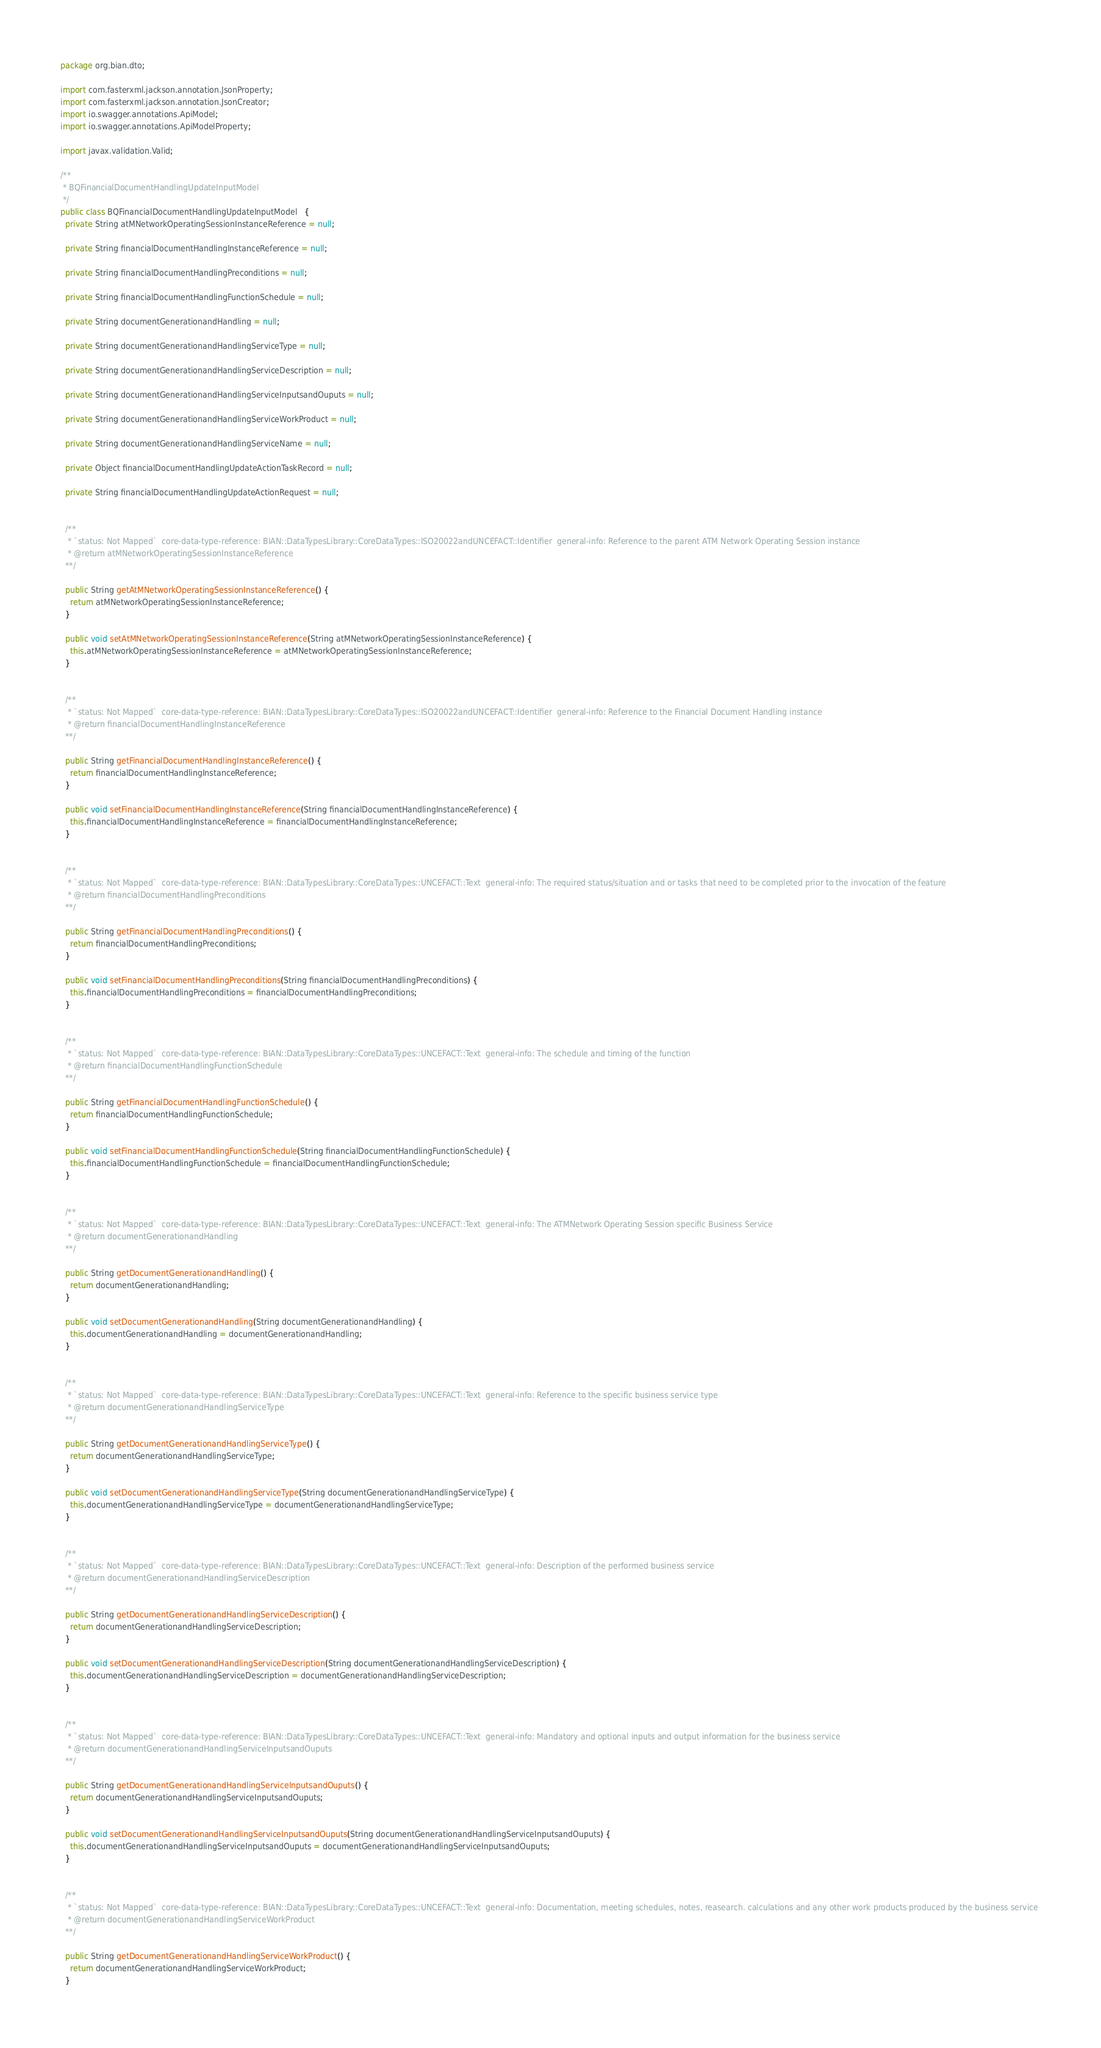<code> <loc_0><loc_0><loc_500><loc_500><_Java_>package org.bian.dto;

import com.fasterxml.jackson.annotation.JsonProperty;
import com.fasterxml.jackson.annotation.JsonCreator;
import io.swagger.annotations.ApiModel;
import io.swagger.annotations.ApiModelProperty;

import javax.validation.Valid;
  
/**
 * BQFinancialDocumentHandlingUpdateInputModel
 */
public class BQFinancialDocumentHandlingUpdateInputModel   {
  private String atMNetworkOperatingSessionInstanceReference = null;

  private String financialDocumentHandlingInstanceReference = null;

  private String financialDocumentHandlingPreconditions = null;

  private String financialDocumentHandlingFunctionSchedule = null;

  private String documentGenerationandHandling = null;

  private String documentGenerationandHandlingServiceType = null;

  private String documentGenerationandHandlingServiceDescription = null;

  private String documentGenerationandHandlingServiceInputsandOuputs = null;

  private String documentGenerationandHandlingServiceWorkProduct = null;

  private String documentGenerationandHandlingServiceName = null;

  private Object financialDocumentHandlingUpdateActionTaskRecord = null;

  private String financialDocumentHandlingUpdateActionRequest = null;


  /**
   * `status: Not Mapped`  core-data-type-reference: BIAN::DataTypesLibrary::CoreDataTypes::ISO20022andUNCEFACT::Identifier  general-info: Reference to the parent ATM Network Operating Session instance 
   * @return atMNetworkOperatingSessionInstanceReference
  **/

  public String getAtMNetworkOperatingSessionInstanceReference() {
    return atMNetworkOperatingSessionInstanceReference;
  }

  public void setAtMNetworkOperatingSessionInstanceReference(String atMNetworkOperatingSessionInstanceReference) {
    this.atMNetworkOperatingSessionInstanceReference = atMNetworkOperatingSessionInstanceReference;
  }


  /**
   * `status: Not Mapped`  core-data-type-reference: BIAN::DataTypesLibrary::CoreDataTypes::ISO20022andUNCEFACT::Identifier  general-info: Reference to the Financial Document Handling instance 
   * @return financialDocumentHandlingInstanceReference
  **/

  public String getFinancialDocumentHandlingInstanceReference() {
    return financialDocumentHandlingInstanceReference;
  }

  public void setFinancialDocumentHandlingInstanceReference(String financialDocumentHandlingInstanceReference) {
    this.financialDocumentHandlingInstanceReference = financialDocumentHandlingInstanceReference;
  }


  /**
   * `status: Not Mapped`  core-data-type-reference: BIAN::DataTypesLibrary::CoreDataTypes::UNCEFACT::Text  general-info: The required status/situation and or tasks that need to be completed prior to the invocation of the feature 
   * @return financialDocumentHandlingPreconditions
  **/

  public String getFinancialDocumentHandlingPreconditions() {
    return financialDocumentHandlingPreconditions;
  }

  public void setFinancialDocumentHandlingPreconditions(String financialDocumentHandlingPreconditions) {
    this.financialDocumentHandlingPreconditions = financialDocumentHandlingPreconditions;
  }


  /**
   * `status: Not Mapped`  core-data-type-reference: BIAN::DataTypesLibrary::CoreDataTypes::UNCEFACT::Text  general-info: The schedule and timing of the function 
   * @return financialDocumentHandlingFunctionSchedule
  **/

  public String getFinancialDocumentHandlingFunctionSchedule() {
    return financialDocumentHandlingFunctionSchedule;
  }

  public void setFinancialDocumentHandlingFunctionSchedule(String financialDocumentHandlingFunctionSchedule) {
    this.financialDocumentHandlingFunctionSchedule = financialDocumentHandlingFunctionSchedule;
  }


  /**
   * `status: Not Mapped`  core-data-type-reference: BIAN::DataTypesLibrary::CoreDataTypes::UNCEFACT::Text  general-info: The ATMNetwork Operating Session specific Business Service 
   * @return documentGenerationandHandling
  **/

  public String getDocumentGenerationandHandling() {
    return documentGenerationandHandling;
  }

  public void setDocumentGenerationandHandling(String documentGenerationandHandling) {
    this.documentGenerationandHandling = documentGenerationandHandling;
  }


  /**
   * `status: Not Mapped`  core-data-type-reference: BIAN::DataTypesLibrary::CoreDataTypes::UNCEFACT::Text  general-info: Reference to the specific business service type 
   * @return documentGenerationandHandlingServiceType
  **/

  public String getDocumentGenerationandHandlingServiceType() {
    return documentGenerationandHandlingServiceType;
  }

  public void setDocumentGenerationandHandlingServiceType(String documentGenerationandHandlingServiceType) {
    this.documentGenerationandHandlingServiceType = documentGenerationandHandlingServiceType;
  }


  /**
   * `status: Not Mapped`  core-data-type-reference: BIAN::DataTypesLibrary::CoreDataTypes::UNCEFACT::Text  general-info: Description of the performed business service 
   * @return documentGenerationandHandlingServiceDescription
  **/

  public String getDocumentGenerationandHandlingServiceDescription() {
    return documentGenerationandHandlingServiceDescription;
  }

  public void setDocumentGenerationandHandlingServiceDescription(String documentGenerationandHandlingServiceDescription) {
    this.documentGenerationandHandlingServiceDescription = documentGenerationandHandlingServiceDescription;
  }


  /**
   * `status: Not Mapped`  core-data-type-reference: BIAN::DataTypesLibrary::CoreDataTypes::UNCEFACT::Text  general-info: Mandatory and optional inputs and output information for the business service 
   * @return documentGenerationandHandlingServiceInputsandOuputs
  **/

  public String getDocumentGenerationandHandlingServiceInputsandOuputs() {
    return documentGenerationandHandlingServiceInputsandOuputs;
  }

  public void setDocumentGenerationandHandlingServiceInputsandOuputs(String documentGenerationandHandlingServiceInputsandOuputs) {
    this.documentGenerationandHandlingServiceInputsandOuputs = documentGenerationandHandlingServiceInputsandOuputs;
  }


  /**
   * `status: Not Mapped`  core-data-type-reference: BIAN::DataTypesLibrary::CoreDataTypes::UNCEFACT::Text  general-info: Documentation, meeting schedules, notes, reasearch. calculations and any other work products produced by the business service 
   * @return documentGenerationandHandlingServiceWorkProduct
  **/

  public String getDocumentGenerationandHandlingServiceWorkProduct() {
    return documentGenerationandHandlingServiceWorkProduct;
  }
</code> 